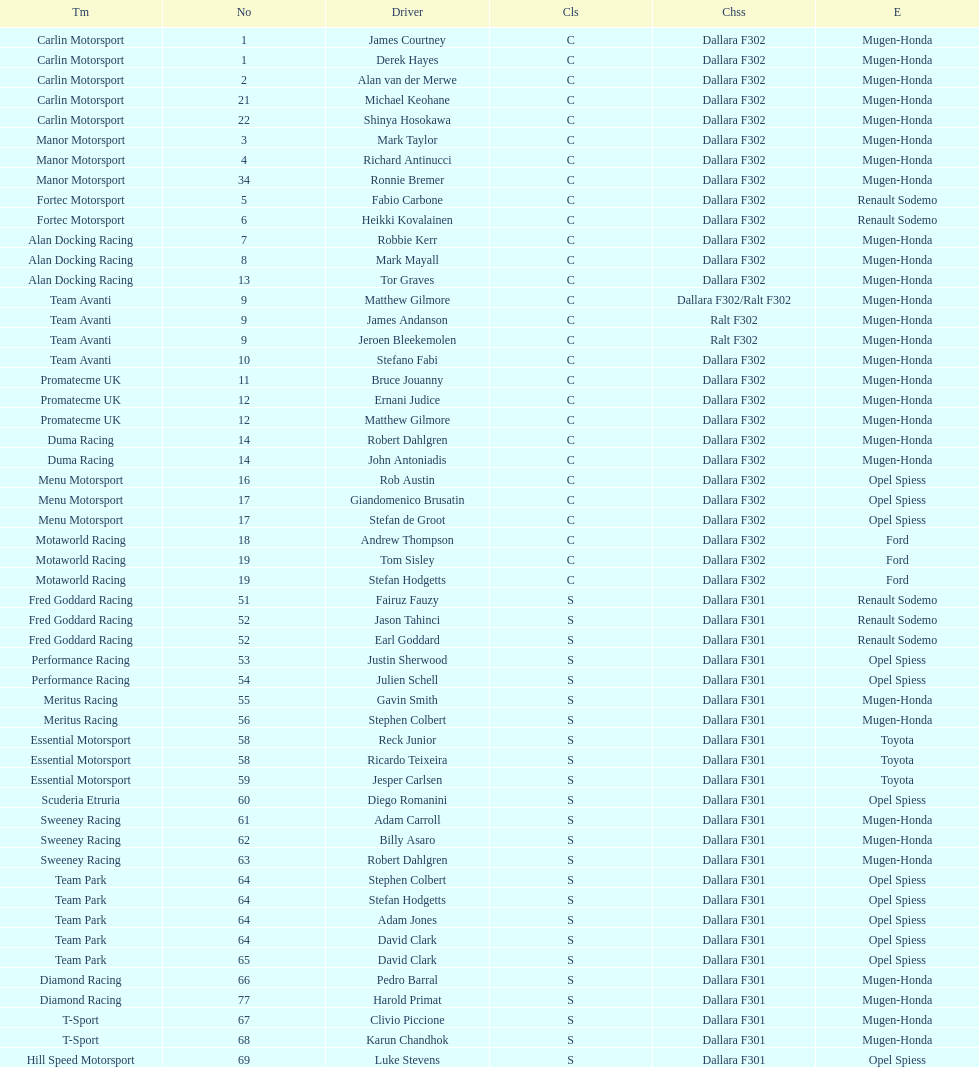How many teams had at least two drivers this season? 17. 